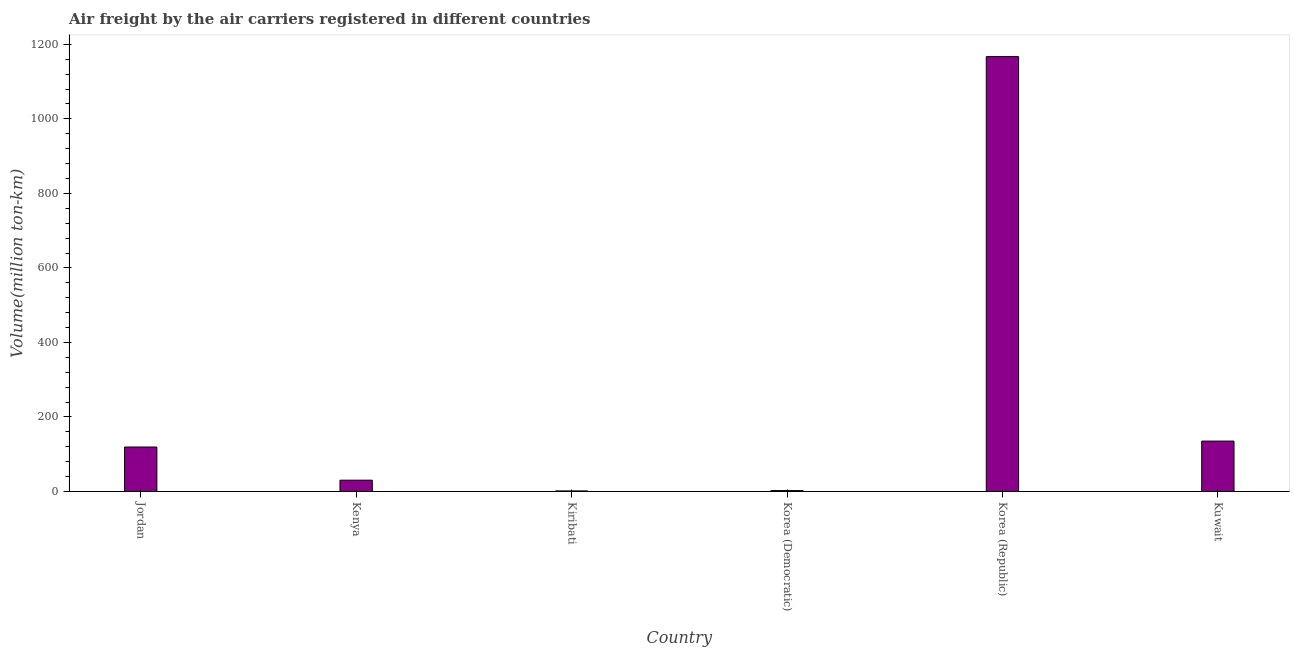What is the title of the graph?
Provide a short and direct response. Air freight by the air carriers registered in different countries. What is the label or title of the Y-axis?
Your answer should be very brief. Volume(million ton-km). What is the air freight in Korea (Republic)?
Your answer should be compact. 1167.1. Across all countries, what is the maximum air freight?
Your answer should be very brief. 1167.1. In which country was the air freight minimum?
Provide a succinct answer. Kiribati. What is the sum of the air freight?
Your response must be concise. 1455.8. What is the difference between the air freight in Kenya and Kuwait?
Make the answer very short. -104.9. What is the average air freight per country?
Keep it short and to the point. 242.63. What is the median air freight?
Keep it short and to the point. 74.8. What is the ratio of the air freight in Kenya to that in Kiribati?
Your answer should be very brief. 20.2. Is the air freight in Kenya less than that in Kiribati?
Keep it short and to the point. No. Is the difference between the air freight in Kenya and Kiribati greater than the difference between any two countries?
Your response must be concise. No. What is the difference between the highest and the second highest air freight?
Provide a short and direct response. 1031.9. What is the difference between the highest and the lowest air freight?
Offer a terse response. 1165.6. In how many countries, is the air freight greater than the average air freight taken over all countries?
Your answer should be compact. 1. What is the Volume(million ton-km) in Jordan?
Make the answer very short. 119.3. What is the Volume(million ton-km) of Kenya?
Make the answer very short. 30.3. What is the Volume(million ton-km) in Korea (Democratic)?
Your response must be concise. 2.4. What is the Volume(million ton-km) of Korea (Republic)?
Give a very brief answer. 1167.1. What is the Volume(million ton-km) of Kuwait?
Provide a short and direct response. 135.2. What is the difference between the Volume(million ton-km) in Jordan and Kenya?
Ensure brevity in your answer.  89. What is the difference between the Volume(million ton-km) in Jordan and Kiribati?
Your answer should be compact. 117.8. What is the difference between the Volume(million ton-km) in Jordan and Korea (Democratic)?
Provide a succinct answer. 116.9. What is the difference between the Volume(million ton-km) in Jordan and Korea (Republic)?
Offer a terse response. -1047.8. What is the difference between the Volume(million ton-km) in Jordan and Kuwait?
Keep it short and to the point. -15.9. What is the difference between the Volume(million ton-km) in Kenya and Kiribati?
Keep it short and to the point. 28.8. What is the difference between the Volume(million ton-km) in Kenya and Korea (Democratic)?
Give a very brief answer. 27.9. What is the difference between the Volume(million ton-km) in Kenya and Korea (Republic)?
Make the answer very short. -1136.8. What is the difference between the Volume(million ton-km) in Kenya and Kuwait?
Offer a terse response. -104.9. What is the difference between the Volume(million ton-km) in Kiribati and Korea (Republic)?
Give a very brief answer. -1165.6. What is the difference between the Volume(million ton-km) in Kiribati and Kuwait?
Make the answer very short. -133.7. What is the difference between the Volume(million ton-km) in Korea (Democratic) and Korea (Republic)?
Make the answer very short. -1164.7. What is the difference between the Volume(million ton-km) in Korea (Democratic) and Kuwait?
Your answer should be very brief. -132.8. What is the difference between the Volume(million ton-km) in Korea (Republic) and Kuwait?
Provide a short and direct response. 1031.9. What is the ratio of the Volume(million ton-km) in Jordan to that in Kenya?
Your answer should be very brief. 3.94. What is the ratio of the Volume(million ton-km) in Jordan to that in Kiribati?
Your response must be concise. 79.53. What is the ratio of the Volume(million ton-km) in Jordan to that in Korea (Democratic)?
Keep it short and to the point. 49.71. What is the ratio of the Volume(million ton-km) in Jordan to that in Korea (Republic)?
Keep it short and to the point. 0.1. What is the ratio of the Volume(million ton-km) in Jordan to that in Kuwait?
Your answer should be very brief. 0.88. What is the ratio of the Volume(million ton-km) in Kenya to that in Kiribati?
Your answer should be compact. 20.2. What is the ratio of the Volume(million ton-km) in Kenya to that in Korea (Democratic)?
Give a very brief answer. 12.62. What is the ratio of the Volume(million ton-km) in Kenya to that in Korea (Republic)?
Offer a very short reply. 0.03. What is the ratio of the Volume(million ton-km) in Kenya to that in Kuwait?
Your answer should be compact. 0.22. What is the ratio of the Volume(million ton-km) in Kiribati to that in Korea (Democratic)?
Give a very brief answer. 0.62. What is the ratio of the Volume(million ton-km) in Kiribati to that in Kuwait?
Your answer should be very brief. 0.01. What is the ratio of the Volume(million ton-km) in Korea (Democratic) to that in Korea (Republic)?
Offer a very short reply. 0. What is the ratio of the Volume(million ton-km) in Korea (Democratic) to that in Kuwait?
Your answer should be compact. 0.02. What is the ratio of the Volume(million ton-km) in Korea (Republic) to that in Kuwait?
Ensure brevity in your answer.  8.63. 